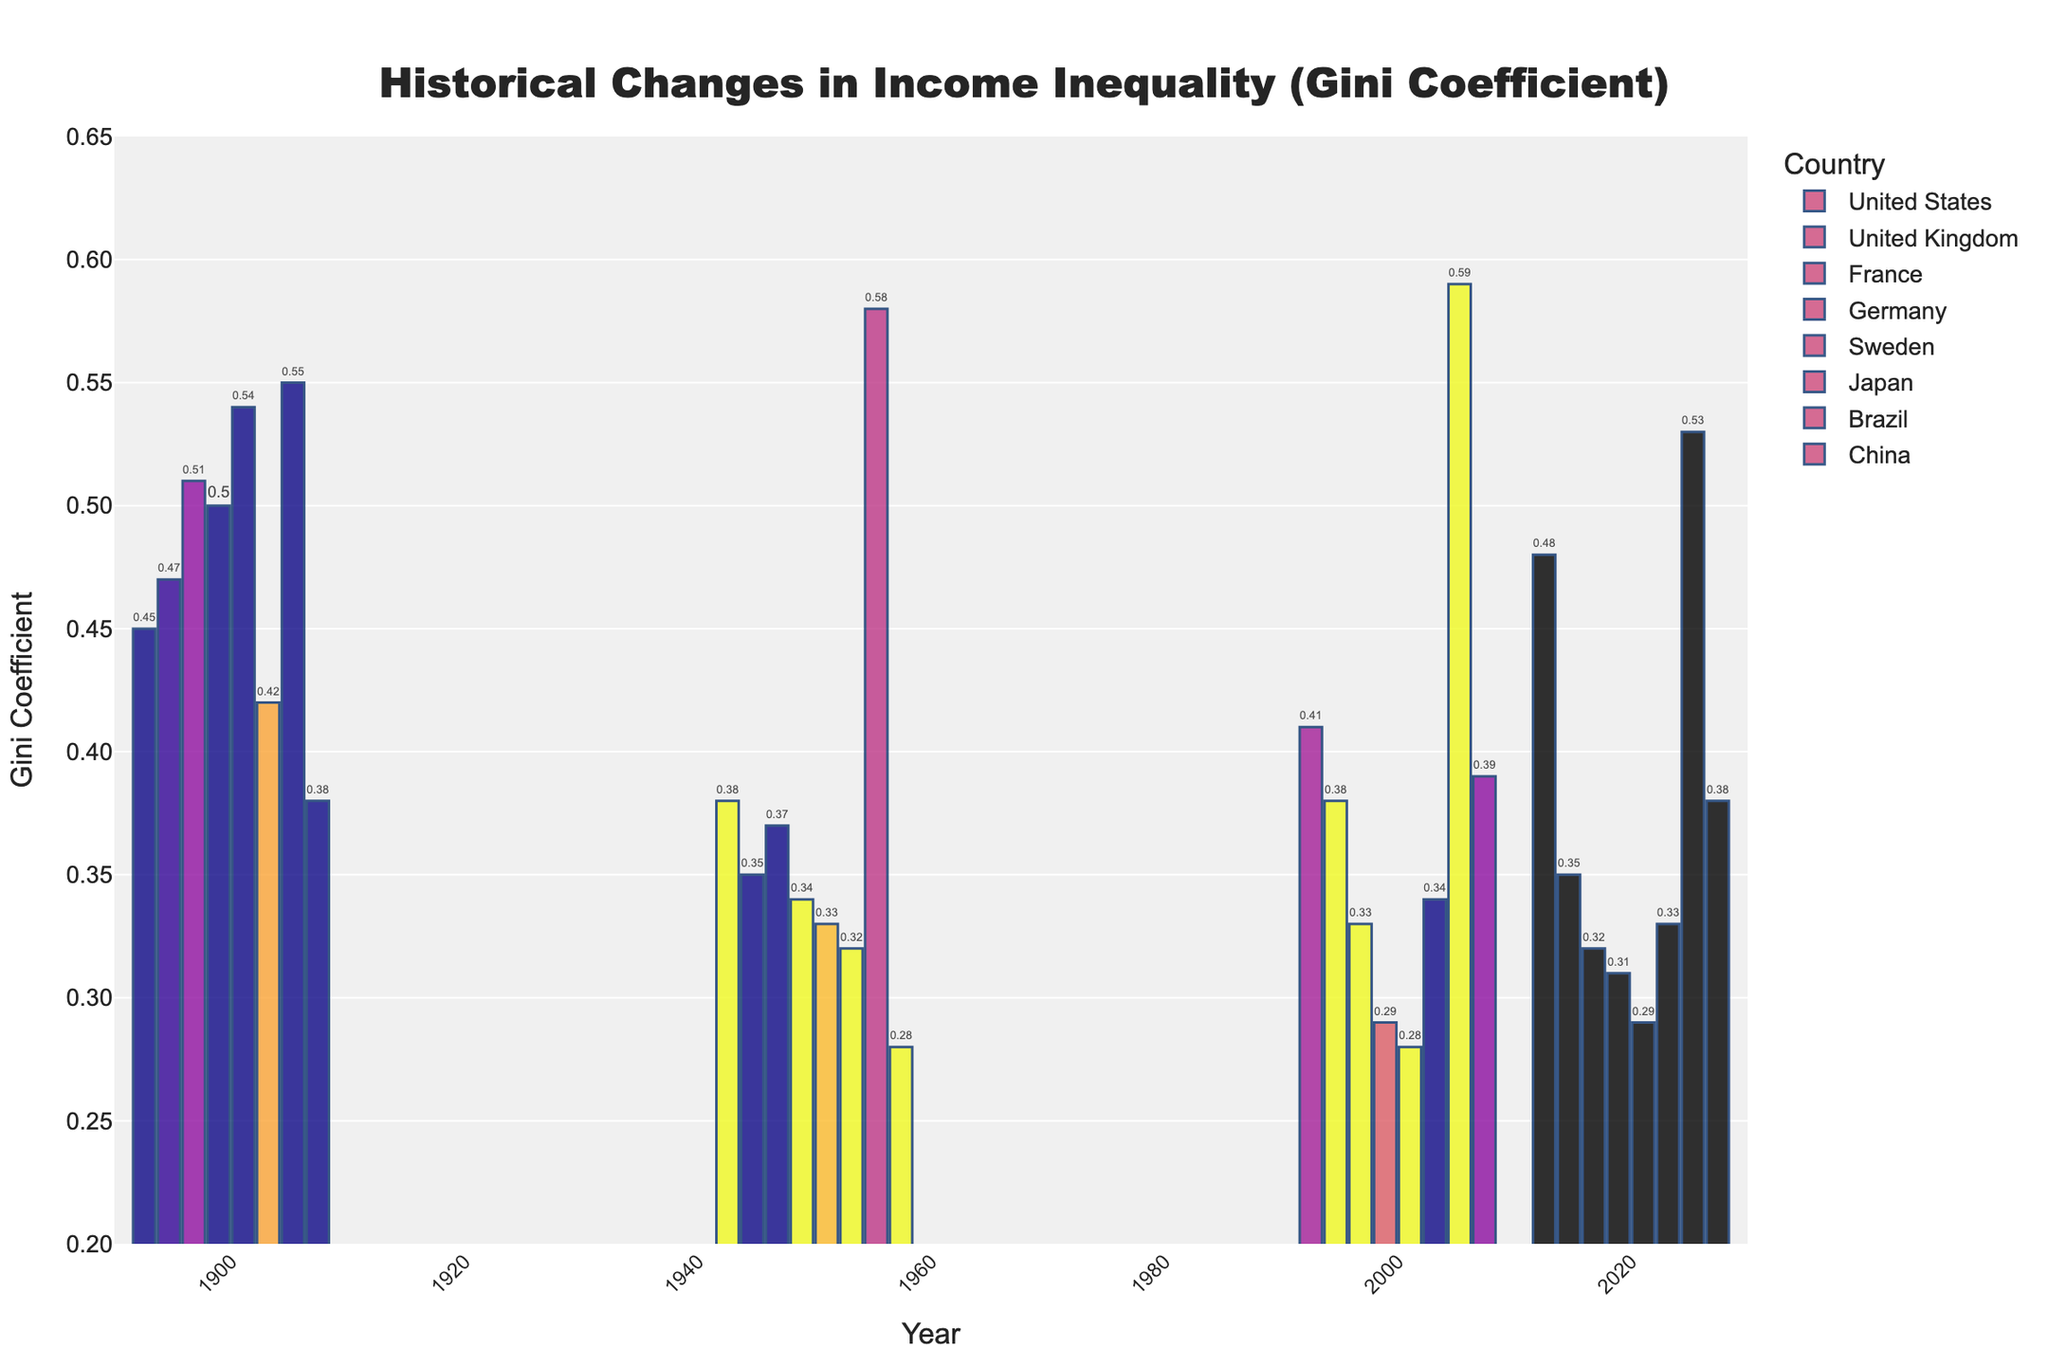Which country had the highest Gini coefficient in 2000? From the bar chart, observe the height of bars for each country for the year 2000. The United States has the highest bar in 2000, indicating the highest Gini coefficient.
Answer: United States How did the Gini coefficient for the United Kingdom change from 1900 to 2020? Identify the bars for the United Kingdom in the years 1900 and 2020. In 1900, the Gini coefficient was high, and by 2020, it had decreased, indicating a reduction in income inequality.
Answer: Decreased Which two countries had the smallest difference in their Gini coefficients in 2020? Look at the bar heights for the year 2020 and compare the differences. France (0.32) and Germany (0.31) had very close Gini coefficients, resulting in the smallest difference.
Answer: France and Germany In which year did Brazil have the highest Gini coefficient? Examine the bars for Brazil across all years. The highest bar for Brazil is in the year 2000.
Answer: 2000 Compare the trend of income inequality in Sweden and Brazil from 1900 to 2020. Observe the bars for Sweden and Brazil over the four time periods. Sweden's Gini coefficient decreased consistently, while Brazil's started high, increased, and then slightly decreased.
Answer: Sweden decreased, Brazil fluctuated Which country showed the most significant reduction in Gini coefficient from 1900 to 1950? Compare the decrease in bar heights between 1900 and 1950 for each country. Germany showed the most significant reduction (0.50 to 0.34).
Answer: Germany Calculate the average Gini coefficient for China across all provided years. Add Gini coefficients for China (0.38, 0.28, 0.39, 0.38) and divide by 4. The sum is 1.43, so the average is 1.43 / 4 = 0.36
Answer: 0.36 Which country had the most stable Gini coefficient values from 1900 to 2020? Compare the bars for the least noticeable changes from 1900 to 2020. Japan shows relatively stable values with minimal fluctuations.
Answer: Japan 